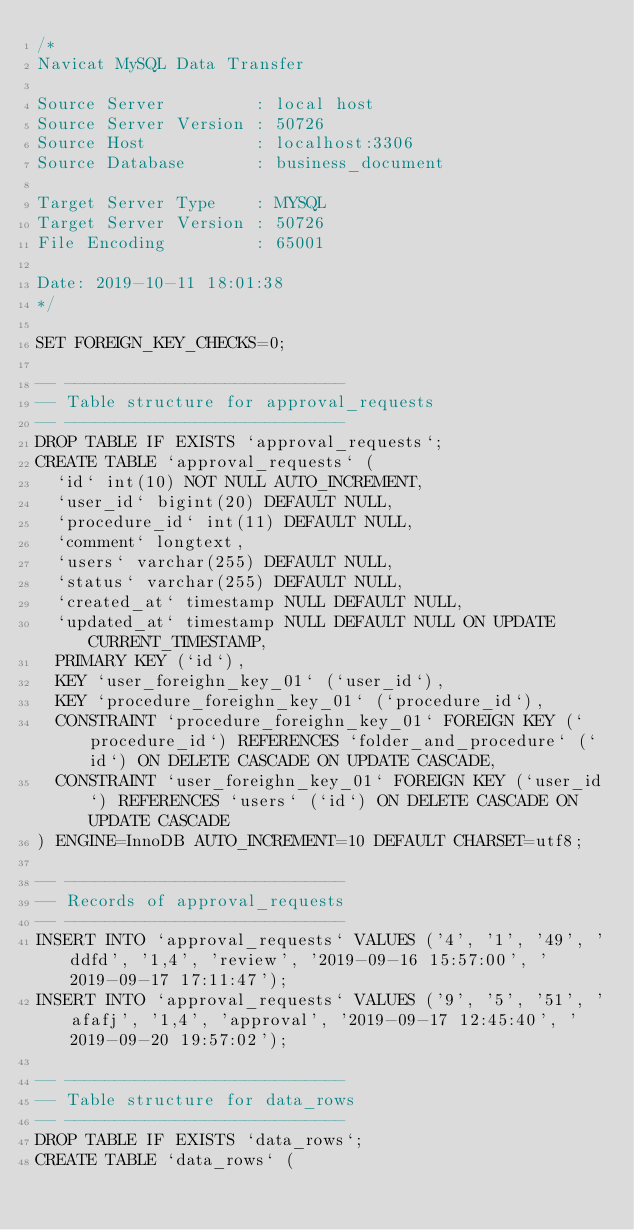<code> <loc_0><loc_0><loc_500><loc_500><_SQL_>/*
Navicat MySQL Data Transfer

Source Server         : local host
Source Server Version : 50726
Source Host           : localhost:3306
Source Database       : business_document

Target Server Type    : MYSQL
Target Server Version : 50726
File Encoding         : 65001

Date: 2019-10-11 18:01:38
*/

SET FOREIGN_KEY_CHECKS=0;

-- ----------------------------
-- Table structure for approval_requests
-- ----------------------------
DROP TABLE IF EXISTS `approval_requests`;
CREATE TABLE `approval_requests` (
  `id` int(10) NOT NULL AUTO_INCREMENT,
  `user_id` bigint(20) DEFAULT NULL,
  `procedure_id` int(11) DEFAULT NULL,
  `comment` longtext,
  `users` varchar(255) DEFAULT NULL,
  `status` varchar(255) DEFAULT NULL,
  `created_at` timestamp NULL DEFAULT NULL,
  `updated_at` timestamp NULL DEFAULT NULL ON UPDATE CURRENT_TIMESTAMP,
  PRIMARY KEY (`id`),
  KEY `user_foreighn_key_01` (`user_id`),
  KEY `procedure_foreighn_key_01` (`procedure_id`),
  CONSTRAINT `procedure_foreighn_key_01` FOREIGN KEY (`procedure_id`) REFERENCES `folder_and_procedure` (`id`) ON DELETE CASCADE ON UPDATE CASCADE,
  CONSTRAINT `user_foreighn_key_01` FOREIGN KEY (`user_id`) REFERENCES `users` (`id`) ON DELETE CASCADE ON UPDATE CASCADE
) ENGINE=InnoDB AUTO_INCREMENT=10 DEFAULT CHARSET=utf8;

-- ----------------------------
-- Records of approval_requests
-- ----------------------------
INSERT INTO `approval_requests` VALUES ('4', '1', '49', 'ddfd', '1,4', 'review', '2019-09-16 15:57:00', '2019-09-17 17:11:47');
INSERT INTO `approval_requests` VALUES ('9', '5', '51', 'afafj', '1,4', 'approval', '2019-09-17 12:45:40', '2019-09-20 19:57:02');

-- ----------------------------
-- Table structure for data_rows
-- ----------------------------
DROP TABLE IF EXISTS `data_rows`;
CREATE TABLE `data_rows` (</code> 